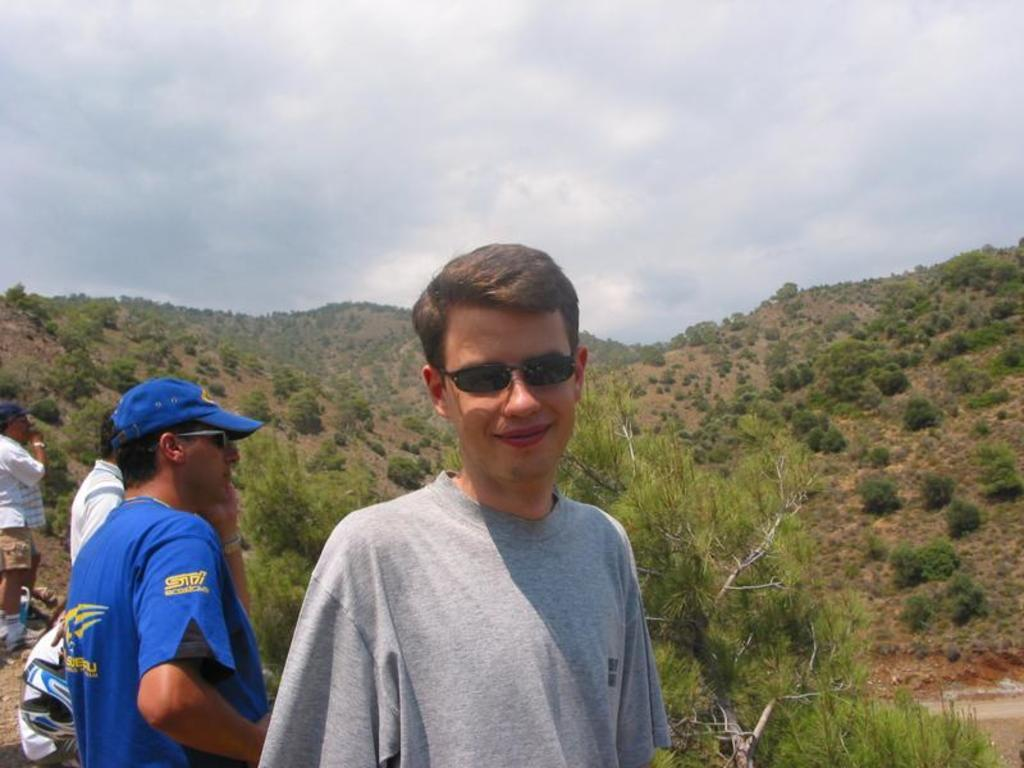How many people are in the image? There is a group of people standing in the image. What can be seen in the background of the image? There is a group of trees on a hill in the background of the image, and the sky is visible. What is the condition of the sky in the image? The sky appears to be cloudy in the image. What type of story is being told by the arm in the image? There is no arm present in the image, and therefore no story can be told by it. 